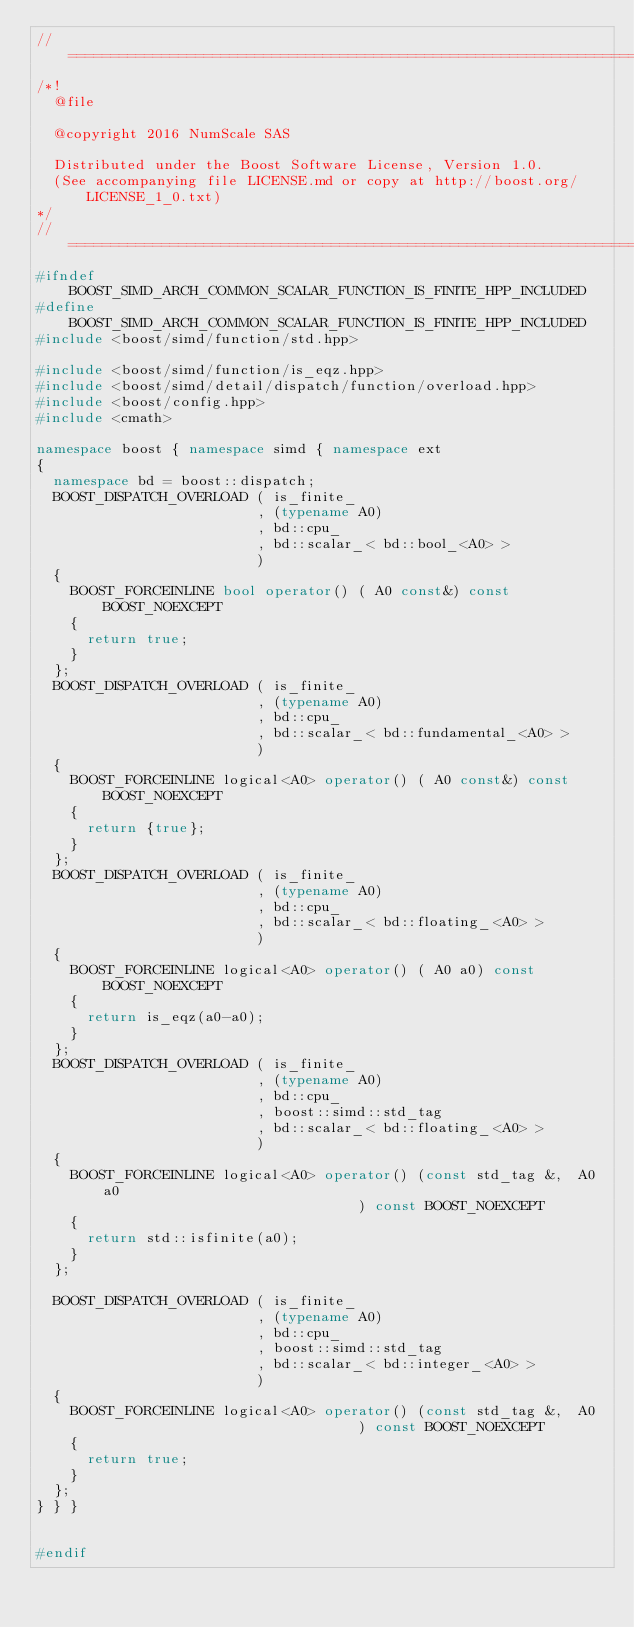<code> <loc_0><loc_0><loc_500><loc_500><_C++_>//==================================================================================================
/*!
  @file

  @copyright 2016 NumScale SAS

  Distributed under the Boost Software License, Version 1.0.
  (See accompanying file LICENSE.md or copy at http://boost.org/LICENSE_1_0.txt)
*/
//==================================================================================================
#ifndef BOOST_SIMD_ARCH_COMMON_SCALAR_FUNCTION_IS_FINITE_HPP_INCLUDED
#define BOOST_SIMD_ARCH_COMMON_SCALAR_FUNCTION_IS_FINITE_HPP_INCLUDED
#include <boost/simd/function/std.hpp>

#include <boost/simd/function/is_eqz.hpp>
#include <boost/simd/detail/dispatch/function/overload.hpp>
#include <boost/config.hpp>
#include <cmath>

namespace boost { namespace simd { namespace ext
{
  namespace bd = boost::dispatch;
  BOOST_DISPATCH_OVERLOAD ( is_finite_
                          , (typename A0)
                          , bd::cpu_
                          , bd::scalar_< bd::bool_<A0> >
                          )
  {
    BOOST_FORCEINLINE bool operator() ( A0 const&) const BOOST_NOEXCEPT
    {
      return true;
    }
  };
  BOOST_DISPATCH_OVERLOAD ( is_finite_
                          , (typename A0)
                          , bd::cpu_
                          , bd::scalar_< bd::fundamental_<A0> >
                          )
  {
    BOOST_FORCEINLINE logical<A0> operator() ( A0 const&) const BOOST_NOEXCEPT
    {
      return {true};
    }
  };
  BOOST_DISPATCH_OVERLOAD ( is_finite_
                          , (typename A0)
                          , bd::cpu_
                          , bd::scalar_< bd::floating_<A0> >
                          )
  {
    BOOST_FORCEINLINE logical<A0> operator() ( A0 a0) const BOOST_NOEXCEPT
    {
      return is_eqz(a0-a0);
    }
  };
  BOOST_DISPATCH_OVERLOAD ( is_finite_
                          , (typename A0)
                          , bd::cpu_
                          , boost::simd::std_tag
                          , bd::scalar_< bd::floating_<A0> >
                          )
  {
    BOOST_FORCEINLINE logical<A0> operator() (const std_tag &,  A0 a0
                                      ) const BOOST_NOEXCEPT
    {
      return std::isfinite(a0);
    }
  };

  BOOST_DISPATCH_OVERLOAD ( is_finite_
                          , (typename A0)
                          , bd::cpu_
                          , boost::simd::std_tag
                          , bd::scalar_< bd::integer_<A0> >
                          )
  {
    BOOST_FORCEINLINE logical<A0> operator() (const std_tag &,  A0
                                      ) const BOOST_NOEXCEPT
    {
      return true;
    }
  };
} } }


#endif
</code> 